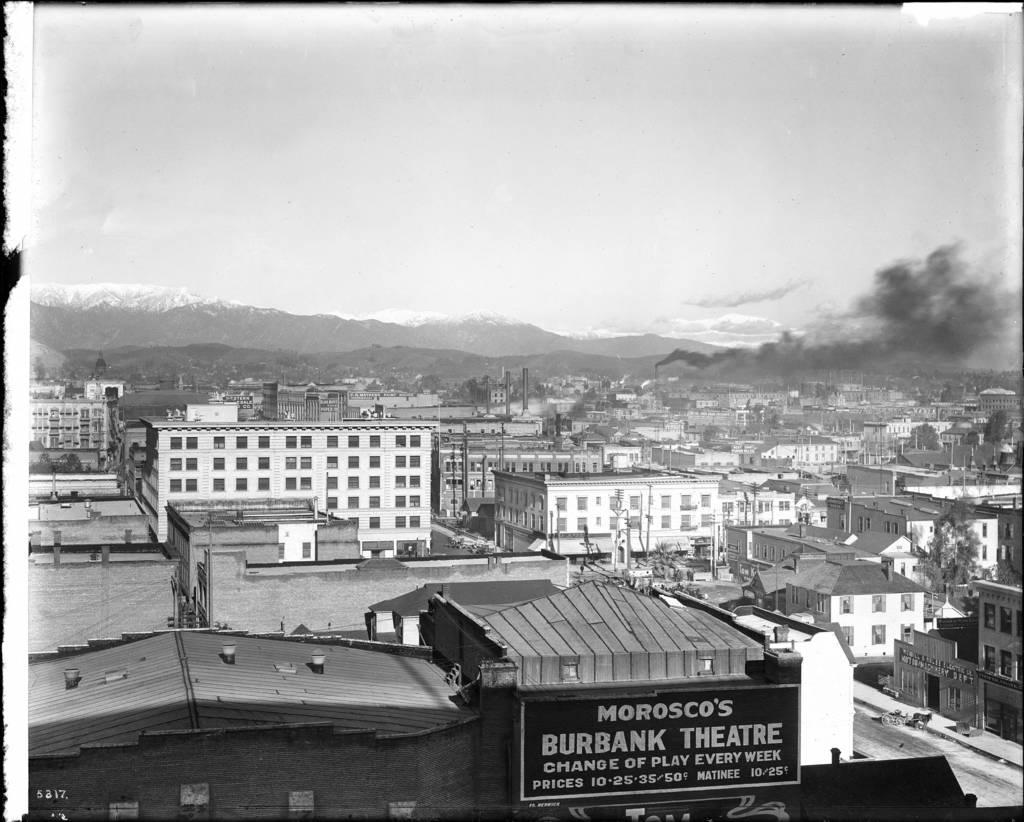<image>
Describe the image concisely. A Morosco's Burbank Theatre can be seen in an old photo 